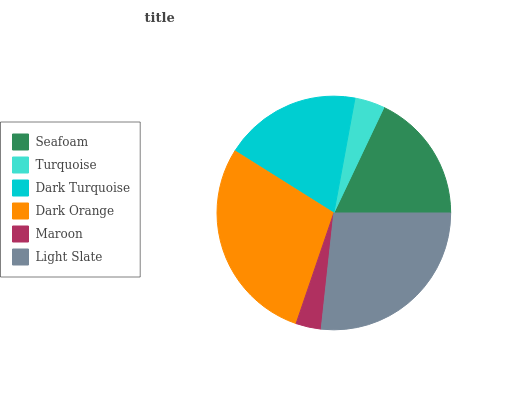Is Maroon the minimum?
Answer yes or no. Yes. Is Dark Orange the maximum?
Answer yes or no. Yes. Is Turquoise the minimum?
Answer yes or no. No. Is Turquoise the maximum?
Answer yes or no. No. Is Seafoam greater than Turquoise?
Answer yes or no. Yes. Is Turquoise less than Seafoam?
Answer yes or no. Yes. Is Turquoise greater than Seafoam?
Answer yes or no. No. Is Seafoam less than Turquoise?
Answer yes or no. No. Is Dark Turquoise the high median?
Answer yes or no. Yes. Is Seafoam the low median?
Answer yes or no. Yes. Is Seafoam the high median?
Answer yes or no. No. Is Dark Orange the low median?
Answer yes or no. No. 